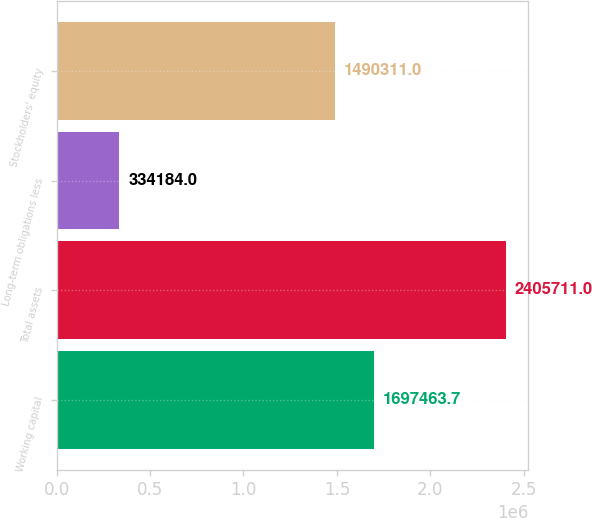Convert chart to OTSL. <chart><loc_0><loc_0><loc_500><loc_500><bar_chart><fcel>Working capital<fcel>Total assets<fcel>Long-term obligations less<fcel>Stockholders' equity<nl><fcel>1.69746e+06<fcel>2.40571e+06<fcel>334184<fcel>1.49031e+06<nl></chart> 